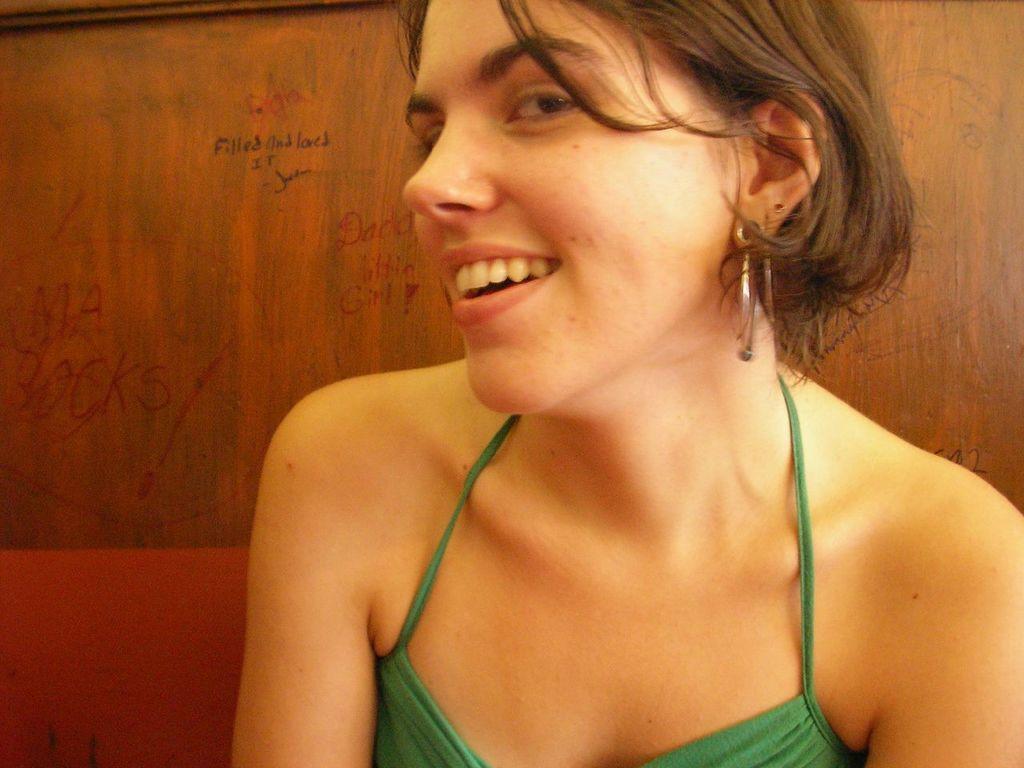Could you give a brief overview of what you see in this image? In this picture there is a girl wearing green top smiling and giving a pose into the camera. Behind there is a wooden panel wall. 